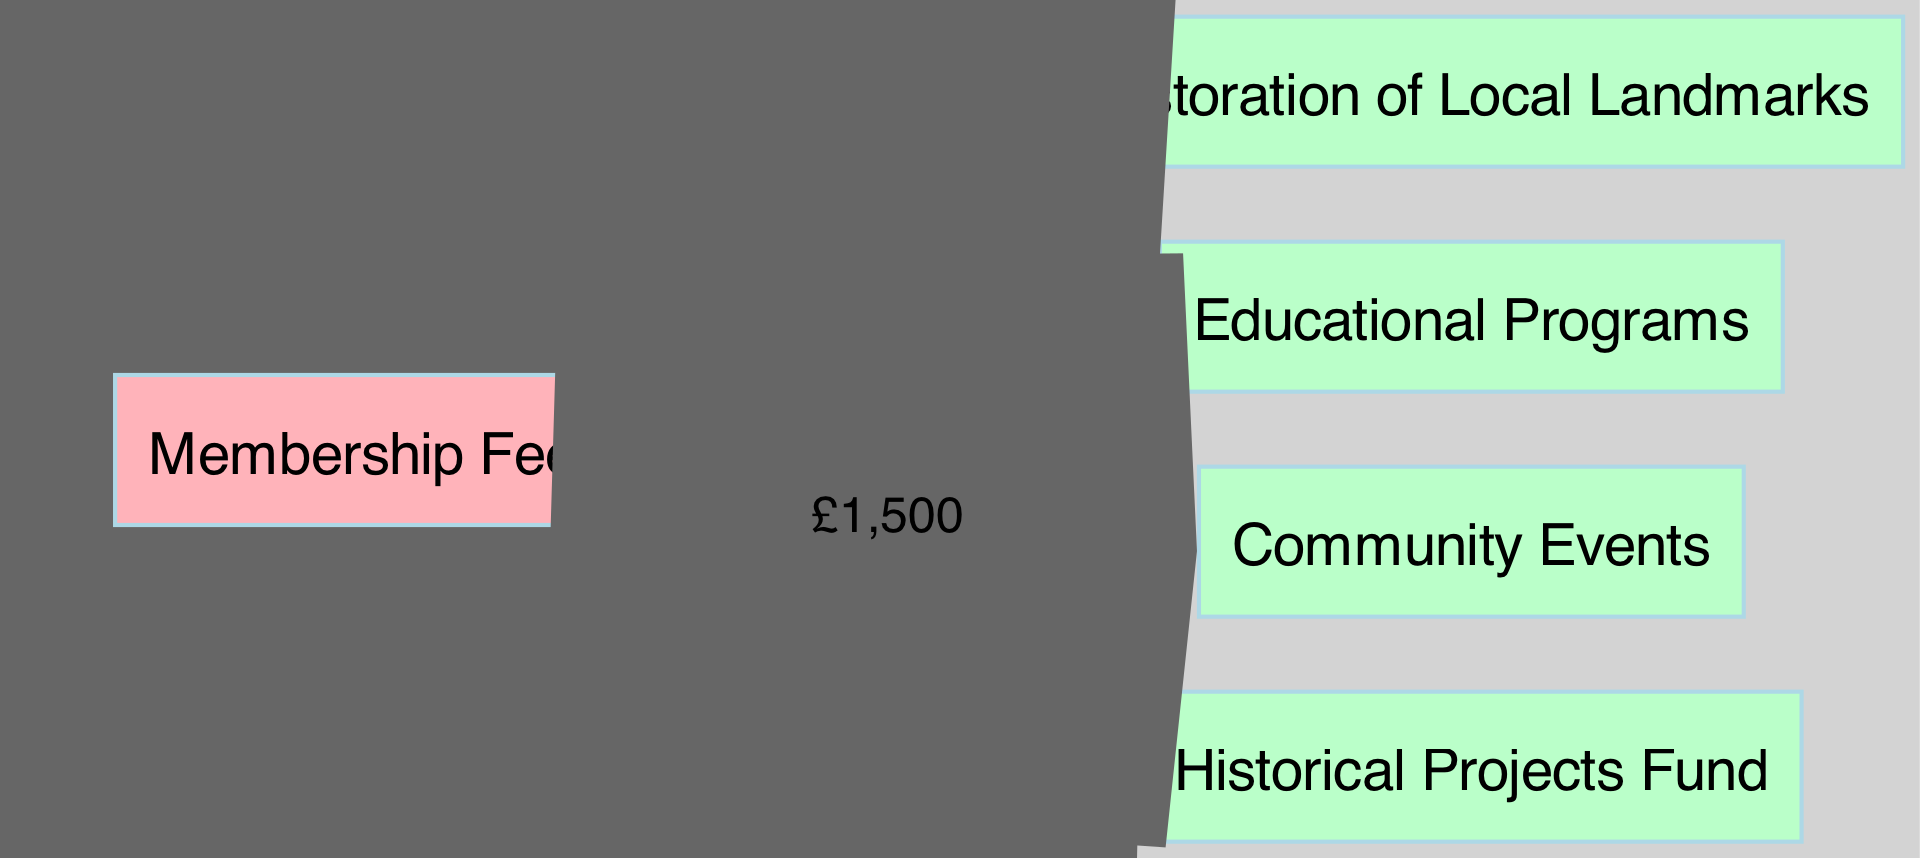What is the total amount from Local Government Grants? The diagram shows that Local Government Grants contribute £5000 to the Historical Projects Fund.
Answer: £5000 How much do Private Donations allocate to Educational Programs? Private Donations are directed towards Educational Programs with an amount of £2000 as indicated in the diagram.
Answer: £2000 Which funding sources contribute to Community Events? The diagram indicates that the only funding source for Community Events is Membership Fees, which contribute £1500.
Answer: Membership Fees How many total sources are there in the diagram? By counting the nodes labeled as sources, we find there are three: Local Government Grants, Private Donations, and Membership Fees.
Answer: 3 What is the total amount allocated to Educational Programs? There are two contributions to Educational Programs: £2000 from Private Donations and £1000 from Membership Fees, totaling £3000.
Answer: £3000 Which destination receives the highest amount from the sources? Examining the amounts, the Historical Projects Fund receives £5000, which is the highest compared to the other destinations.
Answer: Historical Projects Fund How much funding is directed towards Restoration of Local Landmarks? The diagram shows that £3000 from Private Donations is specifically allocated to the Restoration of Local Landmarks.
Answer: £3000 What proportion of Membership Fees goes to Educational Programs? From the Membership Fees of £2500, £1000 goes to Educational Programs, representing 40% of the total Membership Fees.
Answer: 40% Which source has the least total allocation in the diagram? Membership Fees have a total allocation of £2500, which is less than the allocations from Local Government Grants and Private Donations.
Answer: Membership Fees 